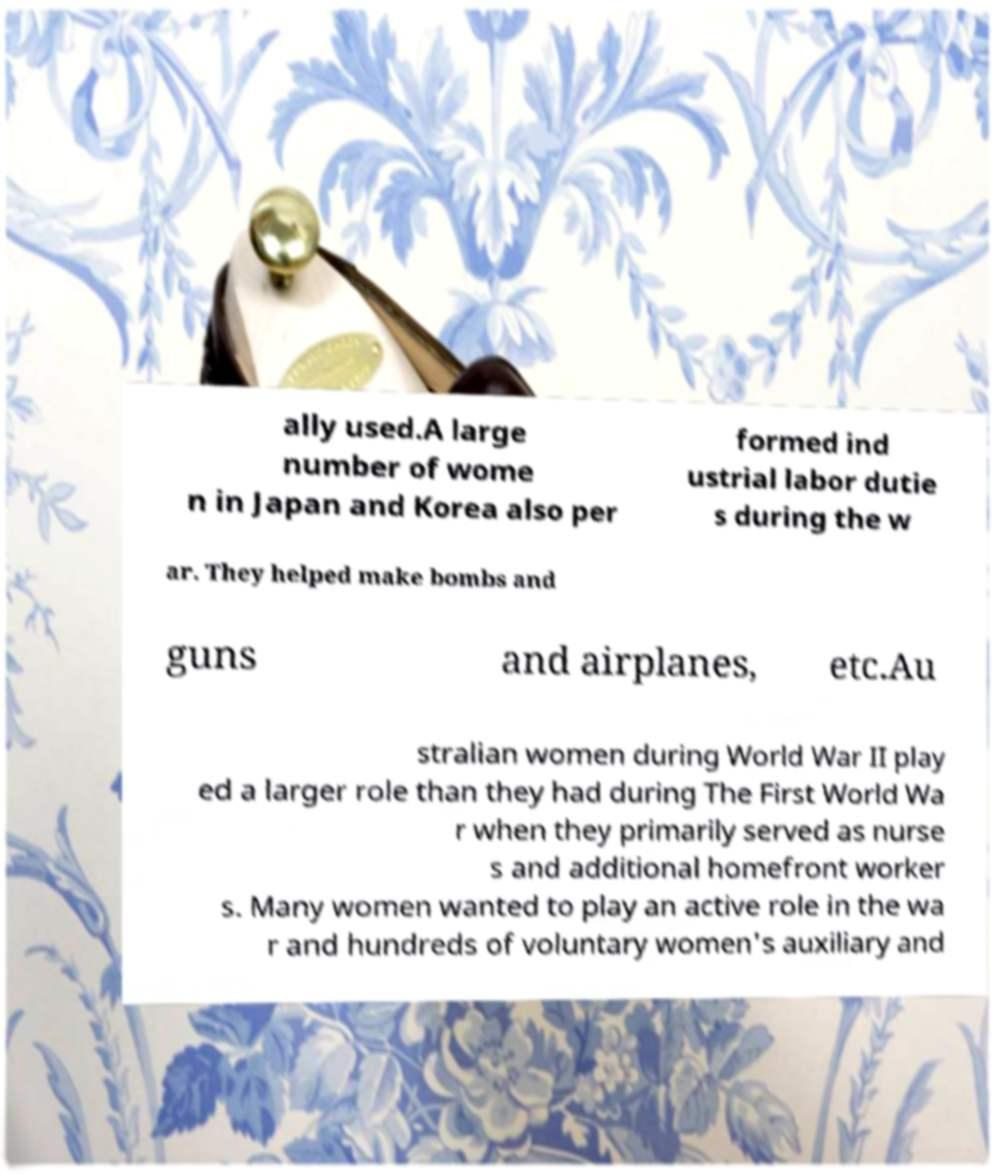Can you accurately transcribe the text from the provided image for me? ally used.A large number of wome n in Japan and Korea also per formed ind ustrial labor dutie s during the w ar. They helped make bombs and guns and airplanes, etc.Au stralian women during World War II play ed a larger role than they had during The First World Wa r when they primarily served as nurse s and additional homefront worker s. Many women wanted to play an active role in the wa r and hundreds of voluntary women's auxiliary and 